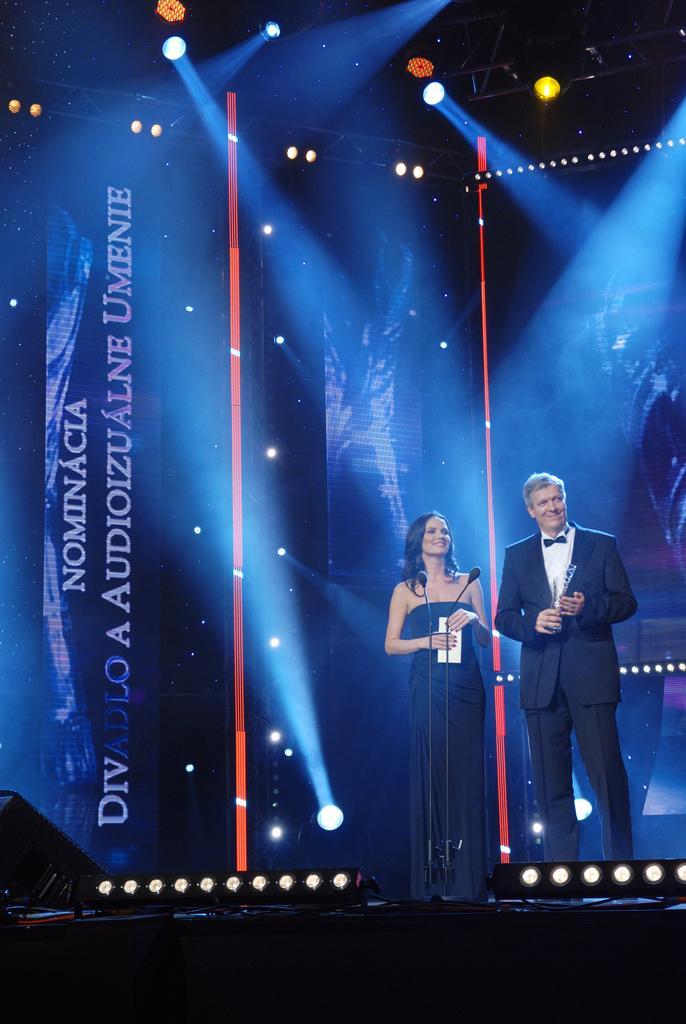Describe this image in one or two sentences. In the image on the stage there is a man with black jacket and lady with black dress is stunning. In front of them there are mics. Behind them there are posters and lights. 